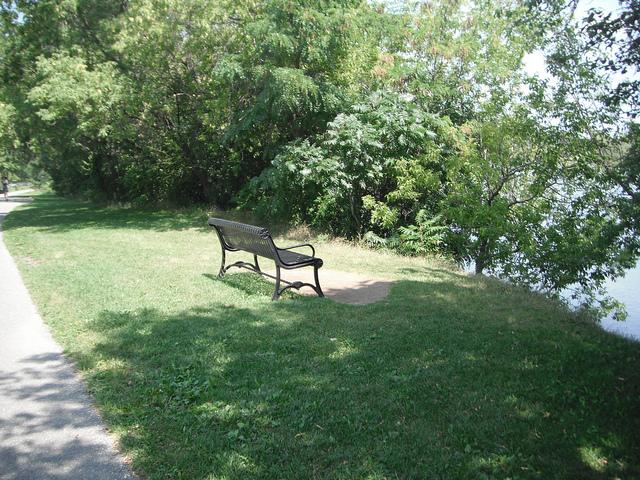What color is the bench?
Concise answer only. Black. Is there a body of water nearby?
Concise answer only. Yes. Who is seated on the bench?
Short answer required. No one. Is the bench empty?
Quick response, please. Yes. 